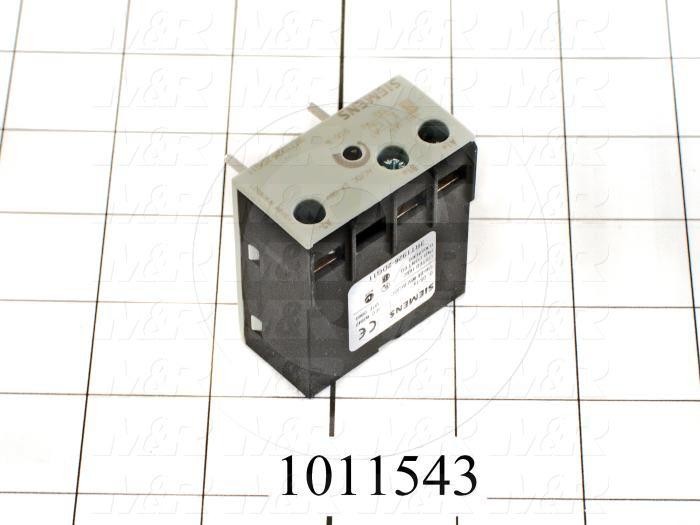Can you describe the type of environment where this electrical component might be installed? This electrical component, given its 16 A rating and general-purpose design, is likely to be installed in environments such as residential homes or commercial buildings. It could be part of an electrical control panel in a household, used to manage power supply to various domestic appliances like lighting systems, air conditioning units, or water heaters. In commercial buildings, it could be used in offices to control lighting circuits or power small machinery and heating elements. The neat and standardized construction suggests it's designed for use within accessible, indoor environments where maintenance and monitoring are feasible. 